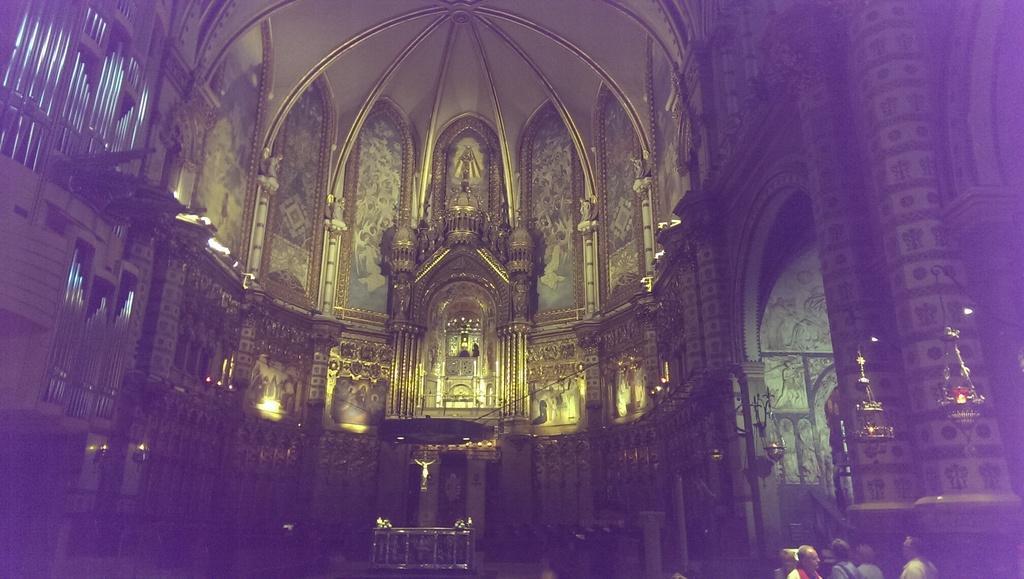Describe this image in one or two sentences. This is taken inside of a church, where we can see the ceiling of a dome, arch, sculptures, candle holder, few persons on the right bottom side of the image. 